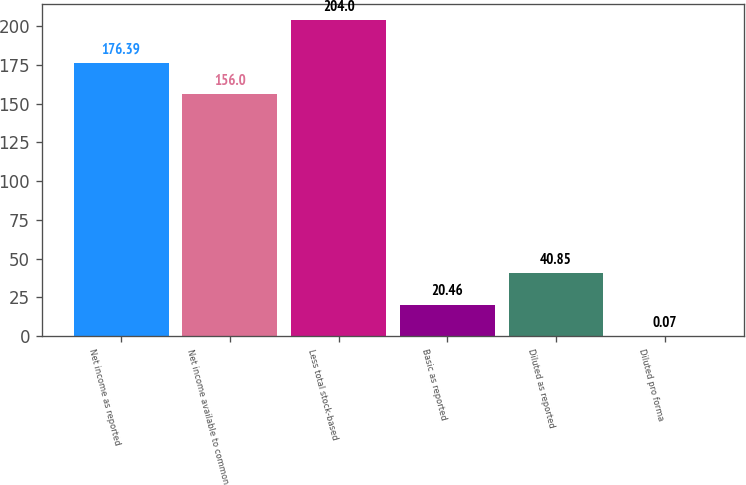Convert chart. <chart><loc_0><loc_0><loc_500><loc_500><bar_chart><fcel>Net income as reported<fcel>Net income available to common<fcel>Less total stock-based<fcel>Basic as reported<fcel>Diluted as reported<fcel>Diluted pro forma<nl><fcel>176.39<fcel>156<fcel>204<fcel>20.46<fcel>40.85<fcel>0.07<nl></chart> 